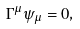<formula> <loc_0><loc_0><loc_500><loc_500>\Gamma ^ { \mu } \psi _ { \mu } = 0 ,</formula> 